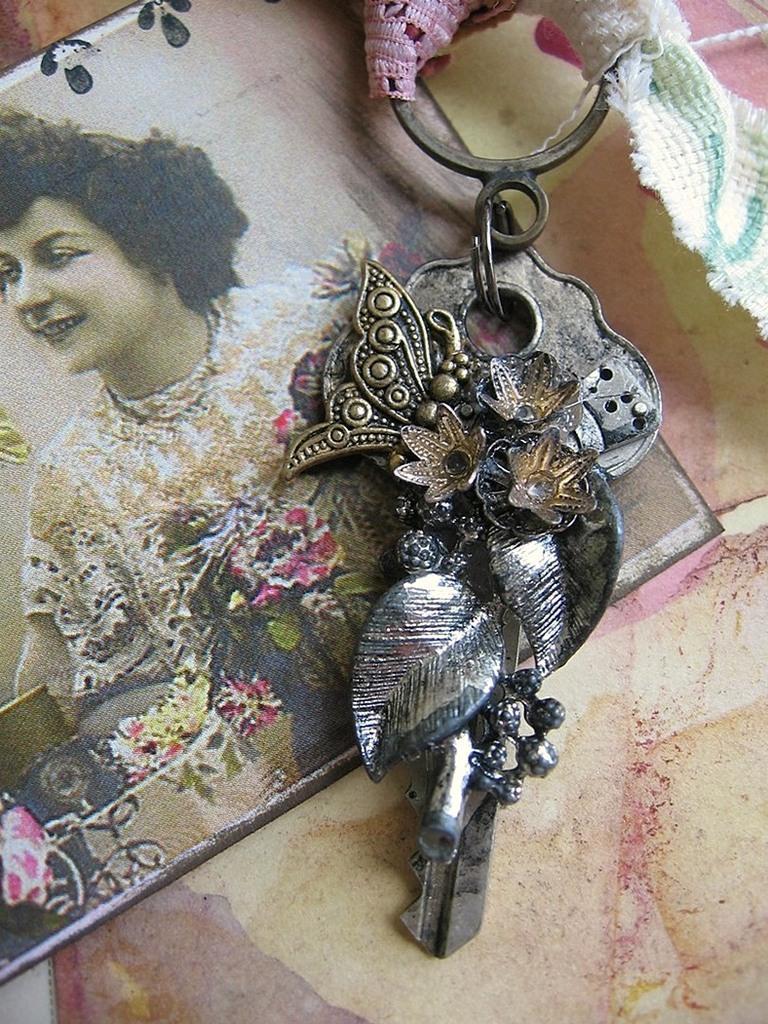Describe this image in one or two sentences. In the picture there is a photo of a woman present, there is a keychain present. 